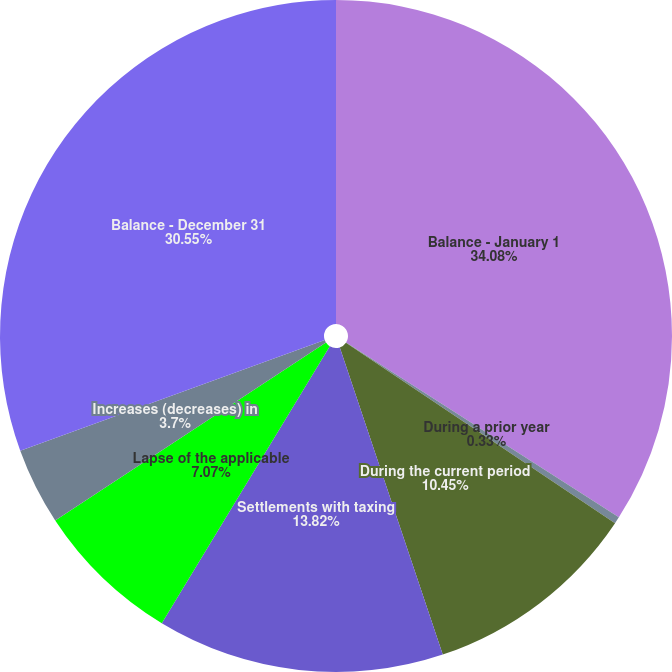<chart> <loc_0><loc_0><loc_500><loc_500><pie_chart><fcel>Balance - January 1<fcel>During a prior year<fcel>During the current period<fcel>Settlements with taxing<fcel>Lapse of the applicable<fcel>Increases (decreases) in<fcel>Balance - December 31<nl><fcel>34.07%<fcel>0.33%<fcel>10.45%<fcel>13.82%<fcel>7.07%<fcel>3.7%<fcel>30.55%<nl></chart> 